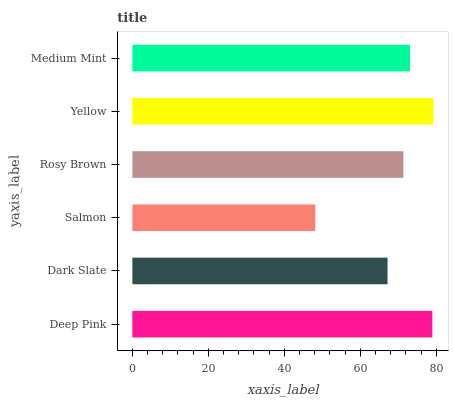Is Salmon the minimum?
Answer yes or no. Yes. Is Yellow the maximum?
Answer yes or no. Yes. Is Dark Slate the minimum?
Answer yes or no. No. Is Dark Slate the maximum?
Answer yes or no. No. Is Deep Pink greater than Dark Slate?
Answer yes or no. Yes. Is Dark Slate less than Deep Pink?
Answer yes or no. Yes. Is Dark Slate greater than Deep Pink?
Answer yes or no. No. Is Deep Pink less than Dark Slate?
Answer yes or no. No. Is Medium Mint the high median?
Answer yes or no. Yes. Is Rosy Brown the low median?
Answer yes or no. Yes. Is Rosy Brown the high median?
Answer yes or no. No. Is Yellow the low median?
Answer yes or no. No. 